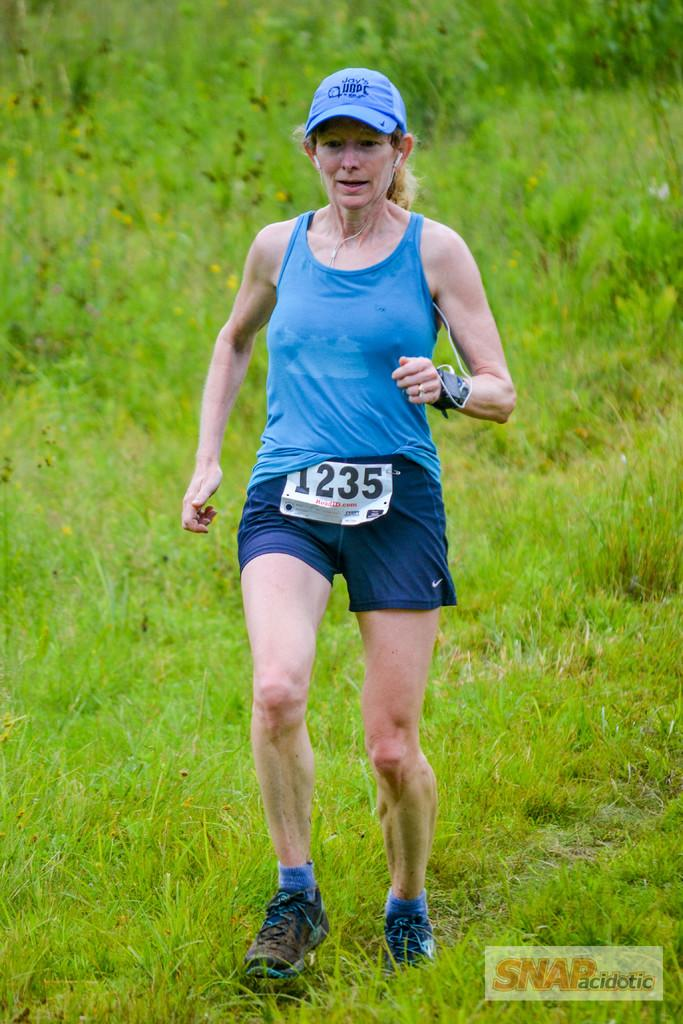<image>
Relay a brief, clear account of the picture shown. A woman in a blue shirt with the number 1235 on her bib runs in a field. 